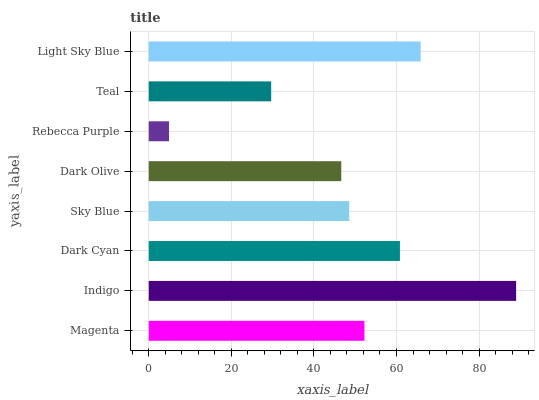Is Rebecca Purple the minimum?
Answer yes or no. Yes. Is Indigo the maximum?
Answer yes or no. Yes. Is Dark Cyan the minimum?
Answer yes or no. No. Is Dark Cyan the maximum?
Answer yes or no. No. Is Indigo greater than Dark Cyan?
Answer yes or no. Yes. Is Dark Cyan less than Indigo?
Answer yes or no. Yes. Is Dark Cyan greater than Indigo?
Answer yes or no. No. Is Indigo less than Dark Cyan?
Answer yes or no. No. Is Magenta the high median?
Answer yes or no. Yes. Is Sky Blue the low median?
Answer yes or no. Yes. Is Teal the high median?
Answer yes or no. No. Is Dark Cyan the low median?
Answer yes or no. No. 